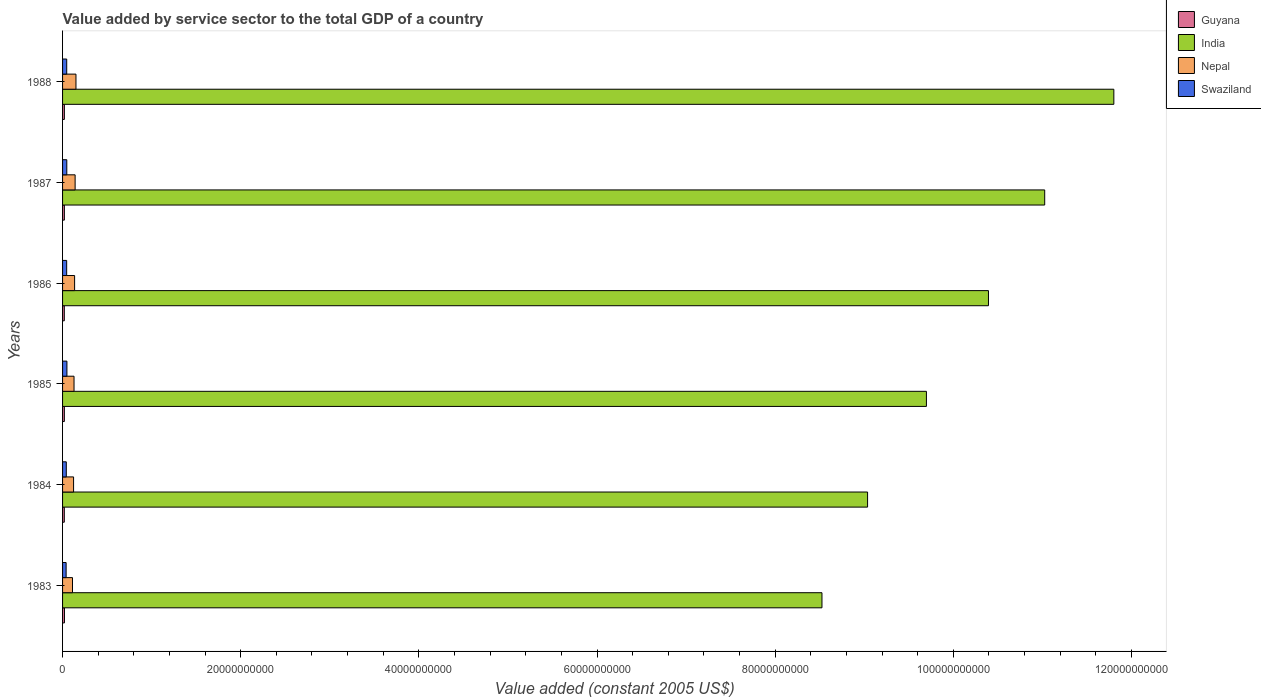How many different coloured bars are there?
Your answer should be very brief. 4. How many groups of bars are there?
Offer a very short reply. 6. Are the number of bars per tick equal to the number of legend labels?
Make the answer very short. Yes. Are the number of bars on each tick of the Y-axis equal?
Give a very brief answer. Yes. What is the label of the 6th group of bars from the top?
Your answer should be compact. 1983. In how many cases, is the number of bars for a given year not equal to the number of legend labels?
Your answer should be very brief. 0. What is the value added by service sector in Guyana in 1987?
Give a very brief answer. 2.04e+08. Across all years, what is the maximum value added by service sector in Swaziland?
Provide a succinct answer. 4.89e+08. Across all years, what is the minimum value added by service sector in India?
Make the answer very short. 8.53e+1. In which year was the value added by service sector in Guyana maximum?
Give a very brief answer. 1983. In which year was the value added by service sector in Swaziland minimum?
Your answer should be compact. 1983. What is the total value added by service sector in Guyana in the graph?
Give a very brief answer. 1.21e+09. What is the difference between the value added by service sector in Swaziland in 1985 and that in 1986?
Offer a terse response. 2.91e+07. What is the difference between the value added by service sector in Nepal in 1985 and the value added by service sector in Guyana in 1984?
Your answer should be compact. 1.09e+09. What is the average value added by service sector in Guyana per year?
Keep it short and to the point. 2.02e+08. In the year 1983, what is the difference between the value added by service sector in Guyana and value added by service sector in India?
Your response must be concise. -8.50e+1. In how many years, is the value added by service sector in Swaziland greater than 100000000000 US$?
Your answer should be very brief. 0. What is the ratio of the value added by service sector in Nepal in 1986 to that in 1987?
Offer a terse response. 0.96. Is the value added by service sector in Nepal in 1985 less than that in 1987?
Give a very brief answer. Yes. Is the difference between the value added by service sector in Guyana in 1984 and 1986 greater than the difference between the value added by service sector in India in 1984 and 1986?
Your answer should be very brief. Yes. What is the difference between the highest and the second highest value added by service sector in Swaziland?
Ensure brevity in your answer.  1.45e+07. What is the difference between the highest and the lowest value added by service sector in Guyana?
Give a very brief answer. 1.72e+07. In how many years, is the value added by service sector in Nepal greater than the average value added by service sector in Nepal taken over all years?
Make the answer very short. 3. What does the 3rd bar from the bottom in 1986 represents?
Offer a terse response. Nepal. Is it the case that in every year, the sum of the value added by service sector in India and value added by service sector in Nepal is greater than the value added by service sector in Guyana?
Make the answer very short. Yes. How many bars are there?
Make the answer very short. 24. How many years are there in the graph?
Make the answer very short. 6. What is the difference between two consecutive major ticks on the X-axis?
Offer a terse response. 2.00e+1. Are the values on the major ticks of X-axis written in scientific E-notation?
Provide a short and direct response. No. How many legend labels are there?
Your response must be concise. 4. How are the legend labels stacked?
Your response must be concise. Vertical. What is the title of the graph?
Provide a succinct answer. Value added by service sector to the total GDP of a country. What is the label or title of the X-axis?
Provide a short and direct response. Value added (constant 2005 US$). What is the label or title of the Y-axis?
Your answer should be very brief. Years. What is the Value added (constant 2005 US$) in Guyana in 1983?
Offer a terse response. 2.13e+08. What is the Value added (constant 2005 US$) of India in 1983?
Provide a succinct answer. 8.53e+1. What is the Value added (constant 2005 US$) in Nepal in 1983?
Ensure brevity in your answer.  1.12e+09. What is the Value added (constant 2005 US$) in Swaziland in 1983?
Give a very brief answer. 3.99e+08. What is the Value added (constant 2005 US$) in Guyana in 1984?
Provide a succinct answer. 1.96e+08. What is the Value added (constant 2005 US$) in India in 1984?
Offer a very short reply. 9.04e+1. What is the Value added (constant 2005 US$) of Nepal in 1984?
Give a very brief answer. 1.24e+09. What is the Value added (constant 2005 US$) in Swaziland in 1984?
Your response must be concise. 4.19e+08. What is the Value added (constant 2005 US$) of Guyana in 1985?
Give a very brief answer. 2.01e+08. What is the Value added (constant 2005 US$) of India in 1985?
Provide a short and direct response. 9.70e+1. What is the Value added (constant 2005 US$) in Nepal in 1985?
Provide a succinct answer. 1.29e+09. What is the Value added (constant 2005 US$) of Swaziland in 1985?
Offer a terse response. 4.89e+08. What is the Value added (constant 2005 US$) in Guyana in 1986?
Offer a very short reply. 1.96e+08. What is the Value added (constant 2005 US$) in India in 1986?
Provide a succinct answer. 1.04e+11. What is the Value added (constant 2005 US$) in Nepal in 1986?
Provide a succinct answer. 1.35e+09. What is the Value added (constant 2005 US$) in Swaziland in 1986?
Provide a short and direct response. 4.60e+08. What is the Value added (constant 2005 US$) of Guyana in 1987?
Make the answer very short. 2.04e+08. What is the Value added (constant 2005 US$) of India in 1987?
Your answer should be very brief. 1.10e+11. What is the Value added (constant 2005 US$) of Nepal in 1987?
Provide a short and direct response. 1.41e+09. What is the Value added (constant 2005 US$) in Swaziland in 1987?
Give a very brief answer. 4.75e+08. What is the Value added (constant 2005 US$) in Guyana in 1988?
Ensure brevity in your answer.  2.03e+08. What is the Value added (constant 2005 US$) in India in 1988?
Keep it short and to the point. 1.18e+11. What is the Value added (constant 2005 US$) in Nepal in 1988?
Keep it short and to the point. 1.50e+09. What is the Value added (constant 2005 US$) in Swaziland in 1988?
Offer a very short reply. 4.66e+08. Across all years, what is the maximum Value added (constant 2005 US$) of Guyana?
Provide a short and direct response. 2.13e+08. Across all years, what is the maximum Value added (constant 2005 US$) of India?
Provide a succinct answer. 1.18e+11. Across all years, what is the maximum Value added (constant 2005 US$) in Nepal?
Offer a terse response. 1.50e+09. Across all years, what is the maximum Value added (constant 2005 US$) in Swaziland?
Your answer should be very brief. 4.89e+08. Across all years, what is the minimum Value added (constant 2005 US$) in Guyana?
Offer a very short reply. 1.96e+08. Across all years, what is the minimum Value added (constant 2005 US$) of India?
Make the answer very short. 8.53e+1. Across all years, what is the minimum Value added (constant 2005 US$) of Nepal?
Provide a short and direct response. 1.12e+09. Across all years, what is the minimum Value added (constant 2005 US$) of Swaziland?
Make the answer very short. 3.99e+08. What is the total Value added (constant 2005 US$) of Guyana in the graph?
Ensure brevity in your answer.  1.21e+09. What is the total Value added (constant 2005 US$) in India in the graph?
Your response must be concise. 6.05e+11. What is the total Value added (constant 2005 US$) of Nepal in the graph?
Your answer should be compact. 7.91e+09. What is the total Value added (constant 2005 US$) of Swaziland in the graph?
Your answer should be compact. 2.71e+09. What is the difference between the Value added (constant 2005 US$) of Guyana in 1983 and that in 1984?
Provide a succinct answer. 1.72e+07. What is the difference between the Value added (constant 2005 US$) in India in 1983 and that in 1984?
Offer a terse response. -5.12e+09. What is the difference between the Value added (constant 2005 US$) in Nepal in 1983 and that in 1984?
Give a very brief answer. -1.20e+08. What is the difference between the Value added (constant 2005 US$) of Swaziland in 1983 and that in 1984?
Offer a very short reply. -2.05e+07. What is the difference between the Value added (constant 2005 US$) in Guyana in 1983 and that in 1985?
Ensure brevity in your answer.  1.17e+07. What is the difference between the Value added (constant 2005 US$) of India in 1983 and that in 1985?
Your response must be concise. -1.17e+1. What is the difference between the Value added (constant 2005 US$) of Nepal in 1983 and that in 1985?
Your response must be concise. -1.70e+08. What is the difference between the Value added (constant 2005 US$) in Swaziland in 1983 and that in 1985?
Ensure brevity in your answer.  -9.06e+07. What is the difference between the Value added (constant 2005 US$) in Guyana in 1983 and that in 1986?
Your answer should be compact. 1.64e+07. What is the difference between the Value added (constant 2005 US$) in India in 1983 and that in 1986?
Your answer should be very brief. -1.87e+1. What is the difference between the Value added (constant 2005 US$) of Nepal in 1983 and that in 1986?
Ensure brevity in your answer.  -2.36e+08. What is the difference between the Value added (constant 2005 US$) in Swaziland in 1983 and that in 1986?
Offer a terse response. -6.15e+07. What is the difference between the Value added (constant 2005 US$) of Guyana in 1983 and that in 1987?
Give a very brief answer. 9.21e+06. What is the difference between the Value added (constant 2005 US$) of India in 1983 and that in 1987?
Ensure brevity in your answer.  -2.50e+1. What is the difference between the Value added (constant 2005 US$) of Nepal in 1983 and that in 1987?
Your response must be concise. -2.94e+08. What is the difference between the Value added (constant 2005 US$) of Swaziland in 1983 and that in 1987?
Ensure brevity in your answer.  -7.61e+07. What is the difference between the Value added (constant 2005 US$) of Guyana in 1983 and that in 1988?
Offer a very short reply. 1.02e+07. What is the difference between the Value added (constant 2005 US$) in India in 1983 and that in 1988?
Your answer should be compact. -3.28e+1. What is the difference between the Value added (constant 2005 US$) in Nepal in 1983 and that in 1988?
Offer a very short reply. -3.89e+08. What is the difference between the Value added (constant 2005 US$) of Swaziland in 1983 and that in 1988?
Keep it short and to the point. -6.75e+07. What is the difference between the Value added (constant 2005 US$) of Guyana in 1984 and that in 1985?
Your response must be concise. -5.50e+06. What is the difference between the Value added (constant 2005 US$) in India in 1984 and that in 1985?
Your answer should be very brief. -6.61e+09. What is the difference between the Value added (constant 2005 US$) in Nepal in 1984 and that in 1985?
Your response must be concise. -4.98e+07. What is the difference between the Value added (constant 2005 US$) of Swaziland in 1984 and that in 1985?
Offer a terse response. -7.01e+07. What is the difference between the Value added (constant 2005 US$) of Guyana in 1984 and that in 1986?
Your answer should be very brief. -7.73e+05. What is the difference between the Value added (constant 2005 US$) in India in 1984 and that in 1986?
Provide a succinct answer. -1.36e+1. What is the difference between the Value added (constant 2005 US$) in Nepal in 1984 and that in 1986?
Offer a very short reply. -1.16e+08. What is the difference between the Value added (constant 2005 US$) of Swaziland in 1984 and that in 1986?
Provide a short and direct response. -4.10e+07. What is the difference between the Value added (constant 2005 US$) in Guyana in 1984 and that in 1987?
Provide a short and direct response. -8.00e+06. What is the difference between the Value added (constant 2005 US$) in India in 1984 and that in 1987?
Ensure brevity in your answer.  -1.99e+1. What is the difference between the Value added (constant 2005 US$) of Nepal in 1984 and that in 1987?
Offer a very short reply. -1.74e+08. What is the difference between the Value added (constant 2005 US$) of Swaziland in 1984 and that in 1987?
Ensure brevity in your answer.  -5.56e+07. What is the difference between the Value added (constant 2005 US$) in Guyana in 1984 and that in 1988?
Offer a very short reply. -7.01e+06. What is the difference between the Value added (constant 2005 US$) of India in 1984 and that in 1988?
Give a very brief answer. -2.76e+1. What is the difference between the Value added (constant 2005 US$) in Nepal in 1984 and that in 1988?
Your answer should be very brief. -2.68e+08. What is the difference between the Value added (constant 2005 US$) of Swaziland in 1984 and that in 1988?
Your answer should be very brief. -4.70e+07. What is the difference between the Value added (constant 2005 US$) of Guyana in 1985 and that in 1986?
Offer a very short reply. 4.73e+06. What is the difference between the Value added (constant 2005 US$) of India in 1985 and that in 1986?
Give a very brief answer. -6.97e+09. What is the difference between the Value added (constant 2005 US$) in Nepal in 1985 and that in 1986?
Give a very brief answer. -6.61e+07. What is the difference between the Value added (constant 2005 US$) of Swaziland in 1985 and that in 1986?
Give a very brief answer. 2.91e+07. What is the difference between the Value added (constant 2005 US$) of Guyana in 1985 and that in 1987?
Your answer should be compact. -2.50e+06. What is the difference between the Value added (constant 2005 US$) in India in 1985 and that in 1987?
Your response must be concise. -1.33e+1. What is the difference between the Value added (constant 2005 US$) in Nepal in 1985 and that in 1987?
Your answer should be very brief. -1.24e+08. What is the difference between the Value added (constant 2005 US$) of Swaziland in 1985 and that in 1987?
Give a very brief answer. 1.45e+07. What is the difference between the Value added (constant 2005 US$) of Guyana in 1985 and that in 1988?
Provide a succinct answer. -1.51e+06. What is the difference between the Value added (constant 2005 US$) in India in 1985 and that in 1988?
Keep it short and to the point. -2.10e+1. What is the difference between the Value added (constant 2005 US$) in Nepal in 1985 and that in 1988?
Your response must be concise. -2.18e+08. What is the difference between the Value added (constant 2005 US$) in Swaziland in 1985 and that in 1988?
Provide a short and direct response. 2.31e+07. What is the difference between the Value added (constant 2005 US$) in Guyana in 1986 and that in 1987?
Keep it short and to the point. -7.23e+06. What is the difference between the Value added (constant 2005 US$) in India in 1986 and that in 1987?
Provide a short and direct response. -6.31e+09. What is the difference between the Value added (constant 2005 US$) in Nepal in 1986 and that in 1987?
Give a very brief answer. -5.78e+07. What is the difference between the Value added (constant 2005 US$) in Swaziland in 1986 and that in 1987?
Provide a succinct answer. -1.46e+07. What is the difference between the Value added (constant 2005 US$) of Guyana in 1986 and that in 1988?
Keep it short and to the point. -6.24e+06. What is the difference between the Value added (constant 2005 US$) of India in 1986 and that in 1988?
Provide a succinct answer. -1.41e+1. What is the difference between the Value added (constant 2005 US$) of Nepal in 1986 and that in 1988?
Keep it short and to the point. -1.52e+08. What is the difference between the Value added (constant 2005 US$) of Swaziland in 1986 and that in 1988?
Give a very brief answer. -6.04e+06. What is the difference between the Value added (constant 2005 US$) in Guyana in 1987 and that in 1988?
Ensure brevity in your answer.  9.89e+05. What is the difference between the Value added (constant 2005 US$) of India in 1987 and that in 1988?
Offer a very short reply. -7.76e+09. What is the difference between the Value added (constant 2005 US$) of Nepal in 1987 and that in 1988?
Provide a succinct answer. -9.44e+07. What is the difference between the Value added (constant 2005 US$) of Swaziland in 1987 and that in 1988?
Your response must be concise. 8.56e+06. What is the difference between the Value added (constant 2005 US$) in Guyana in 1983 and the Value added (constant 2005 US$) in India in 1984?
Your answer should be compact. -9.02e+1. What is the difference between the Value added (constant 2005 US$) in Guyana in 1983 and the Value added (constant 2005 US$) in Nepal in 1984?
Your answer should be compact. -1.02e+09. What is the difference between the Value added (constant 2005 US$) in Guyana in 1983 and the Value added (constant 2005 US$) in Swaziland in 1984?
Provide a short and direct response. -2.07e+08. What is the difference between the Value added (constant 2005 US$) of India in 1983 and the Value added (constant 2005 US$) of Nepal in 1984?
Your response must be concise. 8.40e+1. What is the difference between the Value added (constant 2005 US$) in India in 1983 and the Value added (constant 2005 US$) in Swaziland in 1984?
Provide a short and direct response. 8.48e+1. What is the difference between the Value added (constant 2005 US$) of Nepal in 1983 and the Value added (constant 2005 US$) of Swaziland in 1984?
Keep it short and to the point. 6.97e+08. What is the difference between the Value added (constant 2005 US$) in Guyana in 1983 and the Value added (constant 2005 US$) in India in 1985?
Make the answer very short. -9.68e+1. What is the difference between the Value added (constant 2005 US$) of Guyana in 1983 and the Value added (constant 2005 US$) of Nepal in 1985?
Provide a succinct answer. -1.07e+09. What is the difference between the Value added (constant 2005 US$) of Guyana in 1983 and the Value added (constant 2005 US$) of Swaziland in 1985?
Your response must be concise. -2.77e+08. What is the difference between the Value added (constant 2005 US$) in India in 1983 and the Value added (constant 2005 US$) in Nepal in 1985?
Your answer should be compact. 8.40e+1. What is the difference between the Value added (constant 2005 US$) of India in 1983 and the Value added (constant 2005 US$) of Swaziland in 1985?
Make the answer very short. 8.48e+1. What is the difference between the Value added (constant 2005 US$) in Nepal in 1983 and the Value added (constant 2005 US$) in Swaziland in 1985?
Your answer should be compact. 6.27e+08. What is the difference between the Value added (constant 2005 US$) of Guyana in 1983 and the Value added (constant 2005 US$) of India in 1986?
Your response must be concise. -1.04e+11. What is the difference between the Value added (constant 2005 US$) of Guyana in 1983 and the Value added (constant 2005 US$) of Nepal in 1986?
Your answer should be compact. -1.14e+09. What is the difference between the Value added (constant 2005 US$) of Guyana in 1983 and the Value added (constant 2005 US$) of Swaziland in 1986?
Give a very brief answer. -2.47e+08. What is the difference between the Value added (constant 2005 US$) in India in 1983 and the Value added (constant 2005 US$) in Nepal in 1986?
Keep it short and to the point. 8.39e+1. What is the difference between the Value added (constant 2005 US$) of India in 1983 and the Value added (constant 2005 US$) of Swaziland in 1986?
Your response must be concise. 8.48e+1. What is the difference between the Value added (constant 2005 US$) in Nepal in 1983 and the Value added (constant 2005 US$) in Swaziland in 1986?
Your response must be concise. 6.56e+08. What is the difference between the Value added (constant 2005 US$) in Guyana in 1983 and the Value added (constant 2005 US$) in India in 1987?
Make the answer very short. -1.10e+11. What is the difference between the Value added (constant 2005 US$) in Guyana in 1983 and the Value added (constant 2005 US$) in Nepal in 1987?
Make the answer very short. -1.20e+09. What is the difference between the Value added (constant 2005 US$) in Guyana in 1983 and the Value added (constant 2005 US$) in Swaziland in 1987?
Keep it short and to the point. -2.62e+08. What is the difference between the Value added (constant 2005 US$) of India in 1983 and the Value added (constant 2005 US$) of Nepal in 1987?
Ensure brevity in your answer.  8.38e+1. What is the difference between the Value added (constant 2005 US$) in India in 1983 and the Value added (constant 2005 US$) in Swaziland in 1987?
Your response must be concise. 8.48e+1. What is the difference between the Value added (constant 2005 US$) in Nepal in 1983 and the Value added (constant 2005 US$) in Swaziland in 1987?
Ensure brevity in your answer.  6.41e+08. What is the difference between the Value added (constant 2005 US$) in Guyana in 1983 and the Value added (constant 2005 US$) in India in 1988?
Keep it short and to the point. -1.18e+11. What is the difference between the Value added (constant 2005 US$) of Guyana in 1983 and the Value added (constant 2005 US$) of Nepal in 1988?
Your answer should be very brief. -1.29e+09. What is the difference between the Value added (constant 2005 US$) in Guyana in 1983 and the Value added (constant 2005 US$) in Swaziland in 1988?
Make the answer very short. -2.54e+08. What is the difference between the Value added (constant 2005 US$) in India in 1983 and the Value added (constant 2005 US$) in Nepal in 1988?
Offer a very short reply. 8.37e+1. What is the difference between the Value added (constant 2005 US$) in India in 1983 and the Value added (constant 2005 US$) in Swaziland in 1988?
Provide a succinct answer. 8.48e+1. What is the difference between the Value added (constant 2005 US$) of Nepal in 1983 and the Value added (constant 2005 US$) of Swaziland in 1988?
Give a very brief answer. 6.50e+08. What is the difference between the Value added (constant 2005 US$) of Guyana in 1984 and the Value added (constant 2005 US$) of India in 1985?
Ensure brevity in your answer.  -9.68e+1. What is the difference between the Value added (constant 2005 US$) in Guyana in 1984 and the Value added (constant 2005 US$) in Nepal in 1985?
Your response must be concise. -1.09e+09. What is the difference between the Value added (constant 2005 US$) of Guyana in 1984 and the Value added (constant 2005 US$) of Swaziland in 1985?
Provide a succinct answer. -2.94e+08. What is the difference between the Value added (constant 2005 US$) of India in 1984 and the Value added (constant 2005 US$) of Nepal in 1985?
Offer a very short reply. 8.91e+1. What is the difference between the Value added (constant 2005 US$) of India in 1984 and the Value added (constant 2005 US$) of Swaziland in 1985?
Give a very brief answer. 8.99e+1. What is the difference between the Value added (constant 2005 US$) of Nepal in 1984 and the Value added (constant 2005 US$) of Swaziland in 1985?
Keep it short and to the point. 7.47e+08. What is the difference between the Value added (constant 2005 US$) in Guyana in 1984 and the Value added (constant 2005 US$) in India in 1986?
Make the answer very short. -1.04e+11. What is the difference between the Value added (constant 2005 US$) in Guyana in 1984 and the Value added (constant 2005 US$) in Nepal in 1986?
Your answer should be compact. -1.16e+09. What is the difference between the Value added (constant 2005 US$) of Guyana in 1984 and the Value added (constant 2005 US$) of Swaziland in 1986?
Ensure brevity in your answer.  -2.65e+08. What is the difference between the Value added (constant 2005 US$) in India in 1984 and the Value added (constant 2005 US$) in Nepal in 1986?
Offer a terse response. 8.90e+1. What is the difference between the Value added (constant 2005 US$) of India in 1984 and the Value added (constant 2005 US$) of Swaziland in 1986?
Give a very brief answer. 8.99e+1. What is the difference between the Value added (constant 2005 US$) of Nepal in 1984 and the Value added (constant 2005 US$) of Swaziland in 1986?
Provide a succinct answer. 7.76e+08. What is the difference between the Value added (constant 2005 US$) in Guyana in 1984 and the Value added (constant 2005 US$) in India in 1987?
Give a very brief answer. -1.10e+11. What is the difference between the Value added (constant 2005 US$) of Guyana in 1984 and the Value added (constant 2005 US$) of Nepal in 1987?
Ensure brevity in your answer.  -1.21e+09. What is the difference between the Value added (constant 2005 US$) in Guyana in 1984 and the Value added (constant 2005 US$) in Swaziland in 1987?
Make the answer very short. -2.79e+08. What is the difference between the Value added (constant 2005 US$) in India in 1984 and the Value added (constant 2005 US$) in Nepal in 1987?
Your answer should be compact. 8.90e+1. What is the difference between the Value added (constant 2005 US$) of India in 1984 and the Value added (constant 2005 US$) of Swaziland in 1987?
Your response must be concise. 8.99e+1. What is the difference between the Value added (constant 2005 US$) of Nepal in 1984 and the Value added (constant 2005 US$) of Swaziland in 1987?
Ensure brevity in your answer.  7.62e+08. What is the difference between the Value added (constant 2005 US$) in Guyana in 1984 and the Value added (constant 2005 US$) in India in 1988?
Keep it short and to the point. -1.18e+11. What is the difference between the Value added (constant 2005 US$) in Guyana in 1984 and the Value added (constant 2005 US$) in Nepal in 1988?
Give a very brief answer. -1.31e+09. What is the difference between the Value added (constant 2005 US$) of Guyana in 1984 and the Value added (constant 2005 US$) of Swaziland in 1988?
Provide a succinct answer. -2.71e+08. What is the difference between the Value added (constant 2005 US$) of India in 1984 and the Value added (constant 2005 US$) of Nepal in 1988?
Your answer should be compact. 8.89e+1. What is the difference between the Value added (constant 2005 US$) of India in 1984 and the Value added (constant 2005 US$) of Swaziland in 1988?
Ensure brevity in your answer.  8.99e+1. What is the difference between the Value added (constant 2005 US$) in Nepal in 1984 and the Value added (constant 2005 US$) in Swaziland in 1988?
Offer a terse response. 7.70e+08. What is the difference between the Value added (constant 2005 US$) of Guyana in 1985 and the Value added (constant 2005 US$) of India in 1986?
Your answer should be very brief. -1.04e+11. What is the difference between the Value added (constant 2005 US$) in Guyana in 1985 and the Value added (constant 2005 US$) in Nepal in 1986?
Offer a terse response. -1.15e+09. What is the difference between the Value added (constant 2005 US$) in Guyana in 1985 and the Value added (constant 2005 US$) in Swaziland in 1986?
Offer a terse response. -2.59e+08. What is the difference between the Value added (constant 2005 US$) of India in 1985 and the Value added (constant 2005 US$) of Nepal in 1986?
Provide a succinct answer. 9.56e+1. What is the difference between the Value added (constant 2005 US$) of India in 1985 and the Value added (constant 2005 US$) of Swaziland in 1986?
Keep it short and to the point. 9.65e+1. What is the difference between the Value added (constant 2005 US$) of Nepal in 1985 and the Value added (constant 2005 US$) of Swaziland in 1986?
Offer a very short reply. 8.26e+08. What is the difference between the Value added (constant 2005 US$) of Guyana in 1985 and the Value added (constant 2005 US$) of India in 1987?
Offer a terse response. -1.10e+11. What is the difference between the Value added (constant 2005 US$) of Guyana in 1985 and the Value added (constant 2005 US$) of Nepal in 1987?
Your response must be concise. -1.21e+09. What is the difference between the Value added (constant 2005 US$) of Guyana in 1985 and the Value added (constant 2005 US$) of Swaziland in 1987?
Your answer should be compact. -2.74e+08. What is the difference between the Value added (constant 2005 US$) in India in 1985 and the Value added (constant 2005 US$) in Nepal in 1987?
Make the answer very short. 9.56e+1. What is the difference between the Value added (constant 2005 US$) of India in 1985 and the Value added (constant 2005 US$) of Swaziland in 1987?
Your response must be concise. 9.65e+1. What is the difference between the Value added (constant 2005 US$) of Nepal in 1985 and the Value added (constant 2005 US$) of Swaziland in 1987?
Offer a terse response. 8.11e+08. What is the difference between the Value added (constant 2005 US$) in Guyana in 1985 and the Value added (constant 2005 US$) in India in 1988?
Give a very brief answer. -1.18e+11. What is the difference between the Value added (constant 2005 US$) of Guyana in 1985 and the Value added (constant 2005 US$) of Nepal in 1988?
Offer a terse response. -1.30e+09. What is the difference between the Value added (constant 2005 US$) of Guyana in 1985 and the Value added (constant 2005 US$) of Swaziland in 1988?
Make the answer very short. -2.65e+08. What is the difference between the Value added (constant 2005 US$) in India in 1985 and the Value added (constant 2005 US$) in Nepal in 1988?
Your response must be concise. 9.55e+1. What is the difference between the Value added (constant 2005 US$) of India in 1985 and the Value added (constant 2005 US$) of Swaziland in 1988?
Keep it short and to the point. 9.65e+1. What is the difference between the Value added (constant 2005 US$) of Nepal in 1985 and the Value added (constant 2005 US$) of Swaziland in 1988?
Offer a terse response. 8.20e+08. What is the difference between the Value added (constant 2005 US$) of Guyana in 1986 and the Value added (constant 2005 US$) of India in 1987?
Offer a terse response. -1.10e+11. What is the difference between the Value added (constant 2005 US$) of Guyana in 1986 and the Value added (constant 2005 US$) of Nepal in 1987?
Provide a short and direct response. -1.21e+09. What is the difference between the Value added (constant 2005 US$) in Guyana in 1986 and the Value added (constant 2005 US$) in Swaziland in 1987?
Your answer should be compact. -2.79e+08. What is the difference between the Value added (constant 2005 US$) in India in 1986 and the Value added (constant 2005 US$) in Nepal in 1987?
Give a very brief answer. 1.03e+11. What is the difference between the Value added (constant 2005 US$) of India in 1986 and the Value added (constant 2005 US$) of Swaziland in 1987?
Give a very brief answer. 1.03e+11. What is the difference between the Value added (constant 2005 US$) of Nepal in 1986 and the Value added (constant 2005 US$) of Swaziland in 1987?
Give a very brief answer. 8.78e+08. What is the difference between the Value added (constant 2005 US$) in Guyana in 1986 and the Value added (constant 2005 US$) in India in 1988?
Provide a short and direct response. -1.18e+11. What is the difference between the Value added (constant 2005 US$) in Guyana in 1986 and the Value added (constant 2005 US$) in Nepal in 1988?
Give a very brief answer. -1.31e+09. What is the difference between the Value added (constant 2005 US$) of Guyana in 1986 and the Value added (constant 2005 US$) of Swaziland in 1988?
Your answer should be very brief. -2.70e+08. What is the difference between the Value added (constant 2005 US$) of India in 1986 and the Value added (constant 2005 US$) of Nepal in 1988?
Your answer should be compact. 1.02e+11. What is the difference between the Value added (constant 2005 US$) in India in 1986 and the Value added (constant 2005 US$) in Swaziland in 1988?
Ensure brevity in your answer.  1.03e+11. What is the difference between the Value added (constant 2005 US$) in Nepal in 1986 and the Value added (constant 2005 US$) in Swaziland in 1988?
Your answer should be compact. 8.86e+08. What is the difference between the Value added (constant 2005 US$) of Guyana in 1987 and the Value added (constant 2005 US$) of India in 1988?
Provide a succinct answer. -1.18e+11. What is the difference between the Value added (constant 2005 US$) of Guyana in 1987 and the Value added (constant 2005 US$) of Nepal in 1988?
Offer a very short reply. -1.30e+09. What is the difference between the Value added (constant 2005 US$) of Guyana in 1987 and the Value added (constant 2005 US$) of Swaziland in 1988?
Keep it short and to the point. -2.63e+08. What is the difference between the Value added (constant 2005 US$) in India in 1987 and the Value added (constant 2005 US$) in Nepal in 1988?
Provide a succinct answer. 1.09e+11. What is the difference between the Value added (constant 2005 US$) of India in 1987 and the Value added (constant 2005 US$) of Swaziland in 1988?
Ensure brevity in your answer.  1.10e+11. What is the difference between the Value added (constant 2005 US$) in Nepal in 1987 and the Value added (constant 2005 US$) in Swaziland in 1988?
Keep it short and to the point. 9.44e+08. What is the average Value added (constant 2005 US$) of Guyana per year?
Offer a very short reply. 2.02e+08. What is the average Value added (constant 2005 US$) in India per year?
Your response must be concise. 1.01e+11. What is the average Value added (constant 2005 US$) of Nepal per year?
Provide a succinct answer. 1.32e+09. What is the average Value added (constant 2005 US$) in Swaziland per year?
Offer a terse response. 4.52e+08. In the year 1983, what is the difference between the Value added (constant 2005 US$) of Guyana and Value added (constant 2005 US$) of India?
Provide a short and direct response. -8.50e+1. In the year 1983, what is the difference between the Value added (constant 2005 US$) in Guyana and Value added (constant 2005 US$) in Nepal?
Give a very brief answer. -9.03e+08. In the year 1983, what is the difference between the Value added (constant 2005 US$) in Guyana and Value added (constant 2005 US$) in Swaziland?
Provide a short and direct response. -1.86e+08. In the year 1983, what is the difference between the Value added (constant 2005 US$) in India and Value added (constant 2005 US$) in Nepal?
Ensure brevity in your answer.  8.41e+1. In the year 1983, what is the difference between the Value added (constant 2005 US$) in India and Value added (constant 2005 US$) in Swaziland?
Provide a short and direct response. 8.49e+1. In the year 1983, what is the difference between the Value added (constant 2005 US$) of Nepal and Value added (constant 2005 US$) of Swaziland?
Your answer should be compact. 7.17e+08. In the year 1984, what is the difference between the Value added (constant 2005 US$) of Guyana and Value added (constant 2005 US$) of India?
Offer a very short reply. -9.02e+1. In the year 1984, what is the difference between the Value added (constant 2005 US$) in Guyana and Value added (constant 2005 US$) in Nepal?
Make the answer very short. -1.04e+09. In the year 1984, what is the difference between the Value added (constant 2005 US$) of Guyana and Value added (constant 2005 US$) of Swaziland?
Provide a short and direct response. -2.24e+08. In the year 1984, what is the difference between the Value added (constant 2005 US$) in India and Value added (constant 2005 US$) in Nepal?
Keep it short and to the point. 8.91e+1. In the year 1984, what is the difference between the Value added (constant 2005 US$) in India and Value added (constant 2005 US$) in Swaziland?
Ensure brevity in your answer.  9.00e+1. In the year 1984, what is the difference between the Value added (constant 2005 US$) of Nepal and Value added (constant 2005 US$) of Swaziland?
Provide a short and direct response. 8.17e+08. In the year 1985, what is the difference between the Value added (constant 2005 US$) in Guyana and Value added (constant 2005 US$) in India?
Offer a terse response. -9.68e+1. In the year 1985, what is the difference between the Value added (constant 2005 US$) in Guyana and Value added (constant 2005 US$) in Nepal?
Your answer should be compact. -1.09e+09. In the year 1985, what is the difference between the Value added (constant 2005 US$) of Guyana and Value added (constant 2005 US$) of Swaziland?
Ensure brevity in your answer.  -2.88e+08. In the year 1985, what is the difference between the Value added (constant 2005 US$) of India and Value added (constant 2005 US$) of Nepal?
Your answer should be compact. 9.57e+1. In the year 1985, what is the difference between the Value added (constant 2005 US$) of India and Value added (constant 2005 US$) of Swaziland?
Provide a short and direct response. 9.65e+1. In the year 1985, what is the difference between the Value added (constant 2005 US$) of Nepal and Value added (constant 2005 US$) of Swaziland?
Keep it short and to the point. 7.97e+08. In the year 1986, what is the difference between the Value added (constant 2005 US$) of Guyana and Value added (constant 2005 US$) of India?
Provide a succinct answer. -1.04e+11. In the year 1986, what is the difference between the Value added (constant 2005 US$) in Guyana and Value added (constant 2005 US$) in Nepal?
Your answer should be compact. -1.16e+09. In the year 1986, what is the difference between the Value added (constant 2005 US$) in Guyana and Value added (constant 2005 US$) in Swaziland?
Your answer should be compact. -2.64e+08. In the year 1986, what is the difference between the Value added (constant 2005 US$) of India and Value added (constant 2005 US$) of Nepal?
Your answer should be very brief. 1.03e+11. In the year 1986, what is the difference between the Value added (constant 2005 US$) of India and Value added (constant 2005 US$) of Swaziland?
Your answer should be compact. 1.03e+11. In the year 1986, what is the difference between the Value added (constant 2005 US$) in Nepal and Value added (constant 2005 US$) in Swaziland?
Provide a short and direct response. 8.92e+08. In the year 1987, what is the difference between the Value added (constant 2005 US$) of Guyana and Value added (constant 2005 US$) of India?
Provide a short and direct response. -1.10e+11. In the year 1987, what is the difference between the Value added (constant 2005 US$) of Guyana and Value added (constant 2005 US$) of Nepal?
Offer a very short reply. -1.21e+09. In the year 1987, what is the difference between the Value added (constant 2005 US$) of Guyana and Value added (constant 2005 US$) of Swaziland?
Provide a succinct answer. -2.71e+08. In the year 1987, what is the difference between the Value added (constant 2005 US$) of India and Value added (constant 2005 US$) of Nepal?
Your answer should be compact. 1.09e+11. In the year 1987, what is the difference between the Value added (constant 2005 US$) of India and Value added (constant 2005 US$) of Swaziland?
Give a very brief answer. 1.10e+11. In the year 1987, what is the difference between the Value added (constant 2005 US$) of Nepal and Value added (constant 2005 US$) of Swaziland?
Provide a short and direct response. 9.35e+08. In the year 1988, what is the difference between the Value added (constant 2005 US$) in Guyana and Value added (constant 2005 US$) in India?
Your response must be concise. -1.18e+11. In the year 1988, what is the difference between the Value added (constant 2005 US$) of Guyana and Value added (constant 2005 US$) of Nepal?
Your answer should be very brief. -1.30e+09. In the year 1988, what is the difference between the Value added (constant 2005 US$) of Guyana and Value added (constant 2005 US$) of Swaziland?
Provide a succinct answer. -2.64e+08. In the year 1988, what is the difference between the Value added (constant 2005 US$) of India and Value added (constant 2005 US$) of Nepal?
Ensure brevity in your answer.  1.17e+11. In the year 1988, what is the difference between the Value added (constant 2005 US$) of India and Value added (constant 2005 US$) of Swaziland?
Ensure brevity in your answer.  1.18e+11. In the year 1988, what is the difference between the Value added (constant 2005 US$) of Nepal and Value added (constant 2005 US$) of Swaziland?
Keep it short and to the point. 1.04e+09. What is the ratio of the Value added (constant 2005 US$) in Guyana in 1983 to that in 1984?
Offer a very short reply. 1.09. What is the ratio of the Value added (constant 2005 US$) in India in 1983 to that in 1984?
Provide a short and direct response. 0.94. What is the ratio of the Value added (constant 2005 US$) in Nepal in 1983 to that in 1984?
Keep it short and to the point. 0.9. What is the ratio of the Value added (constant 2005 US$) of Swaziland in 1983 to that in 1984?
Offer a very short reply. 0.95. What is the ratio of the Value added (constant 2005 US$) of Guyana in 1983 to that in 1985?
Offer a very short reply. 1.06. What is the ratio of the Value added (constant 2005 US$) in India in 1983 to that in 1985?
Your response must be concise. 0.88. What is the ratio of the Value added (constant 2005 US$) in Nepal in 1983 to that in 1985?
Ensure brevity in your answer.  0.87. What is the ratio of the Value added (constant 2005 US$) of Swaziland in 1983 to that in 1985?
Your answer should be compact. 0.81. What is the ratio of the Value added (constant 2005 US$) in Guyana in 1983 to that in 1986?
Give a very brief answer. 1.08. What is the ratio of the Value added (constant 2005 US$) of India in 1983 to that in 1986?
Give a very brief answer. 0.82. What is the ratio of the Value added (constant 2005 US$) in Nepal in 1983 to that in 1986?
Your answer should be compact. 0.83. What is the ratio of the Value added (constant 2005 US$) in Swaziland in 1983 to that in 1986?
Offer a very short reply. 0.87. What is the ratio of the Value added (constant 2005 US$) in Guyana in 1983 to that in 1987?
Your answer should be compact. 1.05. What is the ratio of the Value added (constant 2005 US$) in India in 1983 to that in 1987?
Your response must be concise. 0.77. What is the ratio of the Value added (constant 2005 US$) of Nepal in 1983 to that in 1987?
Your response must be concise. 0.79. What is the ratio of the Value added (constant 2005 US$) in Swaziland in 1983 to that in 1987?
Your answer should be very brief. 0.84. What is the ratio of the Value added (constant 2005 US$) in Guyana in 1983 to that in 1988?
Offer a very short reply. 1.05. What is the ratio of the Value added (constant 2005 US$) of India in 1983 to that in 1988?
Your answer should be compact. 0.72. What is the ratio of the Value added (constant 2005 US$) of Nepal in 1983 to that in 1988?
Make the answer very short. 0.74. What is the ratio of the Value added (constant 2005 US$) in Swaziland in 1983 to that in 1988?
Give a very brief answer. 0.86. What is the ratio of the Value added (constant 2005 US$) in Guyana in 1984 to that in 1985?
Keep it short and to the point. 0.97. What is the ratio of the Value added (constant 2005 US$) in India in 1984 to that in 1985?
Make the answer very short. 0.93. What is the ratio of the Value added (constant 2005 US$) of Nepal in 1984 to that in 1985?
Give a very brief answer. 0.96. What is the ratio of the Value added (constant 2005 US$) in Swaziland in 1984 to that in 1985?
Give a very brief answer. 0.86. What is the ratio of the Value added (constant 2005 US$) of Guyana in 1984 to that in 1986?
Ensure brevity in your answer.  1. What is the ratio of the Value added (constant 2005 US$) in India in 1984 to that in 1986?
Offer a terse response. 0.87. What is the ratio of the Value added (constant 2005 US$) of Nepal in 1984 to that in 1986?
Provide a succinct answer. 0.91. What is the ratio of the Value added (constant 2005 US$) of Swaziland in 1984 to that in 1986?
Your answer should be compact. 0.91. What is the ratio of the Value added (constant 2005 US$) in Guyana in 1984 to that in 1987?
Your answer should be very brief. 0.96. What is the ratio of the Value added (constant 2005 US$) in India in 1984 to that in 1987?
Your response must be concise. 0.82. What is the ratio of the Value added (constant 2005 US$) in Nepal in 1984 to that in 1987?
Ensure brevity in your answer.  0.88. What is the ratio of the Value added (constant 2005 US$) of Swaziland in 1984 to that in 1987?
Give a very brief answer. 0.88. What is the ratio of the Value added (constant 2005 US$) of Guyana in 1984 to that in 1988?
Provide a short and direct response. 0.97. What is the ratio of the Value added (constant 2005 US$) in India in 1984 to that in 1988?
Provide a short and direct response. 0.77. What is the ratio of the Value added (constant 2005 US$) in Nepal in 1984 to that in 1988?
Offer a very short reply. 0.82. What is the ratio of the Value added (constant 2005 US$) of Swaziland in 1984 to that in 1988?
Provide a short and direct response. 0.9. What is the ratio of the Value added (constant 2005 US$) of Guyana in 1985 to that in 1986?
Provide a succinct answer. 1.02. What is the ratio of the Value added (constant 2005 US$) in India in 1985 to that in 1986?
Provide a succinct answer. 0.93. What is the ratio of the Value added (constant 2005 US$) of Nepal in 1985 to that in 1986?
Your answer should be compact. 0.95. What is the ratio of the Value added (constant 2005 US$) in Swaziland in 1985 to that in 1986?
Your answer should be compact. 1.06. What is the ratio of the Value added (constant 2005 US$) in India in 1985 to that in 1987?
Ensure brevity in your answer.  0.88. What is the ratio of the Value added (constant 2005 US$) of Nepal in 1985 to that in 1987?
Provide a short and direct response. 0.91. What is the ratio of the Value added (constant 2005 US$) in Swaziland in 1985 to that in 1987?
Make the answer very short. 1.03. What is the ratio of the Value added (constant 2005 US$) in Guyana in 1985 to that in 1988?
Offer a very short reply. 0.99. What is the ratio of the Value added (constant 2005 US$) of India in 1985 to that in 1988?
Offer a very short reply. 0.82. What is the ratio of the Value added (constant 2005 US$) in Nepal in 1985 to that in 1988?
Ensure brevity in your answer.  0.85. What is the ratio of the Value added (constant 2005 US$) in Swaziland in 1985 to that in 1988?
Offer a terse response. 1.05. What is the ratio of the Value added (constant 2005 US$) in Guyana in 1986 to that in 1987?
Your answer should be very brief. 0.96. What is the ratio of the Value added (constant 2005 US$) of India in 1986 to that in 1987?
Make the answer very short. 0.94. What is the ratio of the Value added (constant 2005 US$) of Swaziland in 1986 to that in 1987?
Make the answer very short. 0.97. What is the ratio of the Value added (constant 2005 US$) of Guyana in 1986 to that in 1988?
Offer a terse response. 0.97. What is the ratio of the Value added (constant 2005 US$) in India in 1986 to that in 1988?
Give a very brief answer. 0.88. What is the ratio of the Value added (constant 2005 US$) of Nepal in 1986 to that in 1988?
Your response must be concise. 0.9. What is the ratio of the Value added (constant 2005 US$) of Guyana in 1987 to that in 1988?
Offer a terse response. 1. What is the ratio of the Value added (constant 2005 US$) of India in 1987 to that in 1988?
Your response must be concise. 0.93. What is the ratio of the Value added (constant 2005 US$) in Nepal in 1987 to that in 1988?
Give a very brief answer. 0.94. What is the ratio of the Value added (constant 2005 US$) in Swaziland in 1987 to that in 1988?
Keep it short and to the point. 1.02. What is the difference between the highest and the second highest Value added (constant 2005 US$) of Guyana?
Your answer should be compact. 9.21e+06. What is the difference between the highest and the second highest Value added (constant 2005 US$) in India?
Your response must be concise. 7.76e+09. What is the difference between the highest and the second highest Value added (constant 2005 US$) of Nepal?
Make the answer very short. 9.44e+07. What is the difference between the highest and the second highest Value added (constant 2005 US$) in Swaziland?
Make the answer very short. 1.45e+07. What is the difference between the highest and the lowest Value added (constant 2005 US$) of Guyana?
Offer a terse response. 1.72e+07. What is the difference between the highest and the lowest Value added (constant 2005 US$) in India?
Make the answer very short. 3.28e+1. What is the difference between the highest and the lowest Value added (constant 2005 US$) in Nepal?
Provide a succinct answer. 3.89e+08. What is the difference between the highest and the lowest Value added (constant 2005 US$) of Swaziland?
Keep it short and to the point. 9.06e+07. 